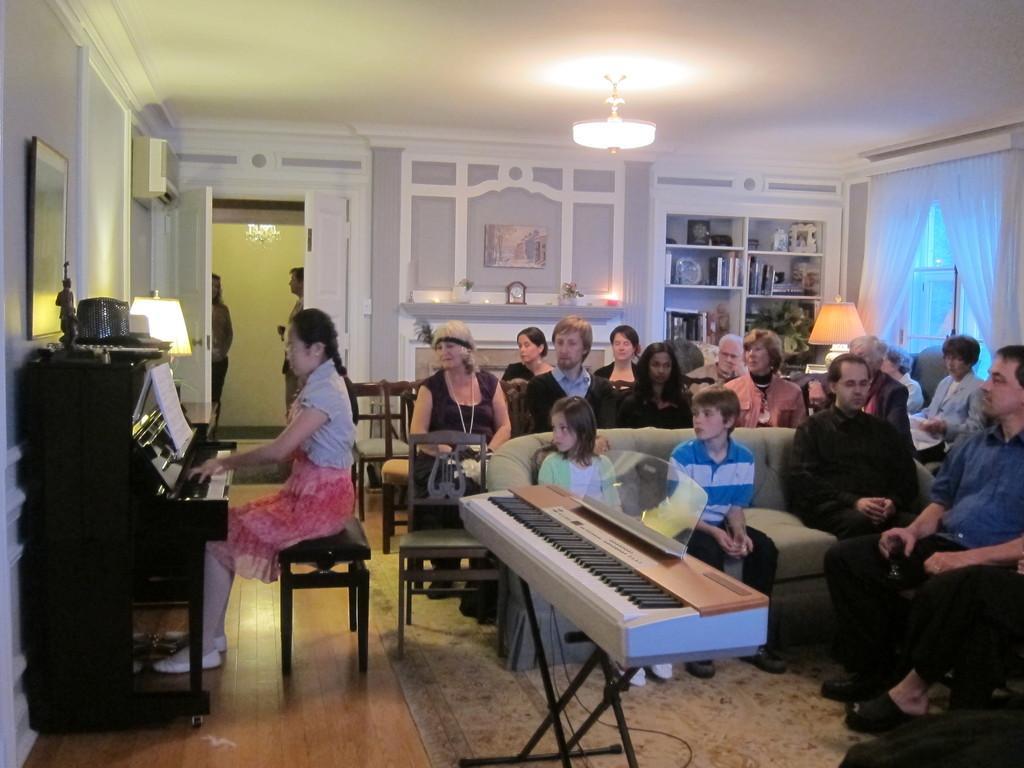How would you summarize this image in a sentence or two? In this image a woman at the left side is sitting and playing a piano. On top of piano there is an idol. Beside to it there is a lamp. On the top of piano a picture frame is attached to the wall and a air conditioner is also fixed to the wall. Beside there is a door where two persons are standing. At right side of image few persons are sitting on chairs and three persons are sitting on sofa. In front side of image there is a piano. Background there is a shelf having some books. Top of roof a light hanged. 